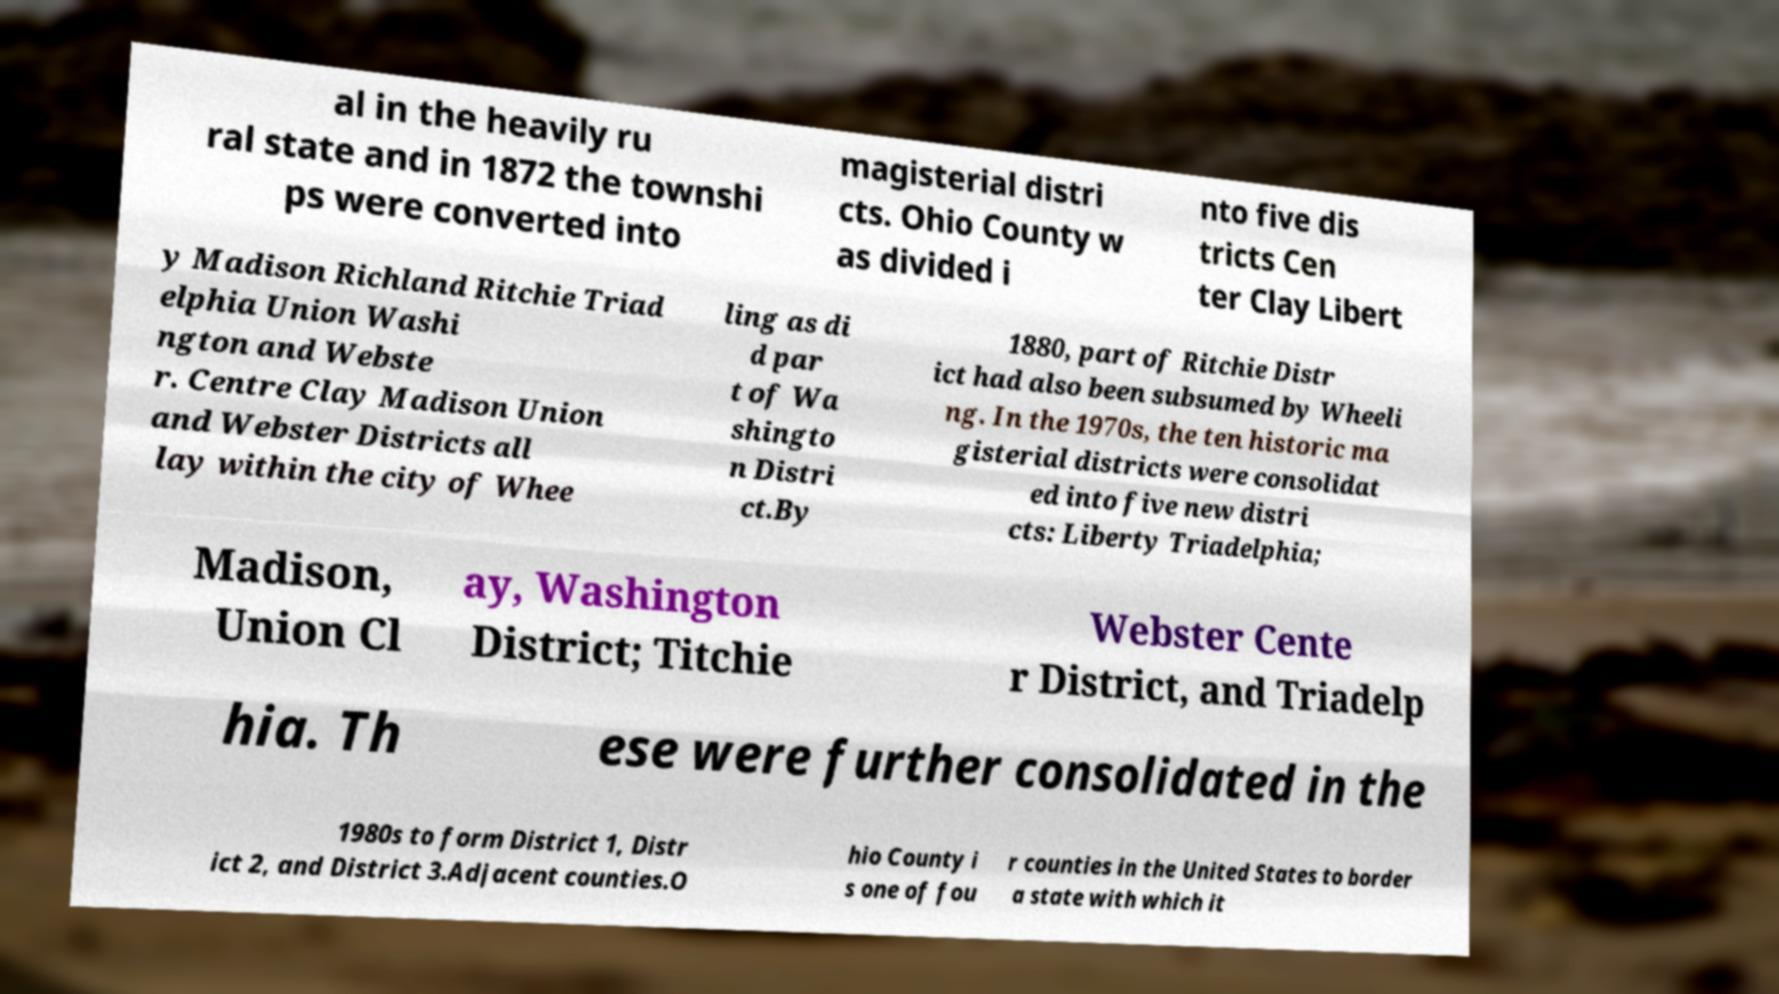Can you accurately transcribe the text from the provided image for me? al in the heavily ru ral state and in 1872 the townshi ps were converted into magisterial distri cts. Ohio County w as divided i nto five dis tricts Cen ter Clay Libert y Madison Richland Ritchie Triad elphia Union Washi ngton and Webste r. Centre Clay Madison Union and Webster Districts all lay within the city of Whee ling as di d par t of Wa shingto n Distri ct.By 1880, part of Ritchie Distr ict had also been subsumed by Wheeli ng. In the 1970s, the ten historic ma gisterial districts were consolidat ed into five new distri cts: Liberty Triadelphia; Madison, Union Cl ay, Washington District; Titchie Webster Cente r District, and Triadelp hia. Th ese were further consolidated in the 1980s to form District 1, Distr ict 2, and District 3.Adjacent counties.O hio County i s one of fou r counties in the United States to border a state with which it 